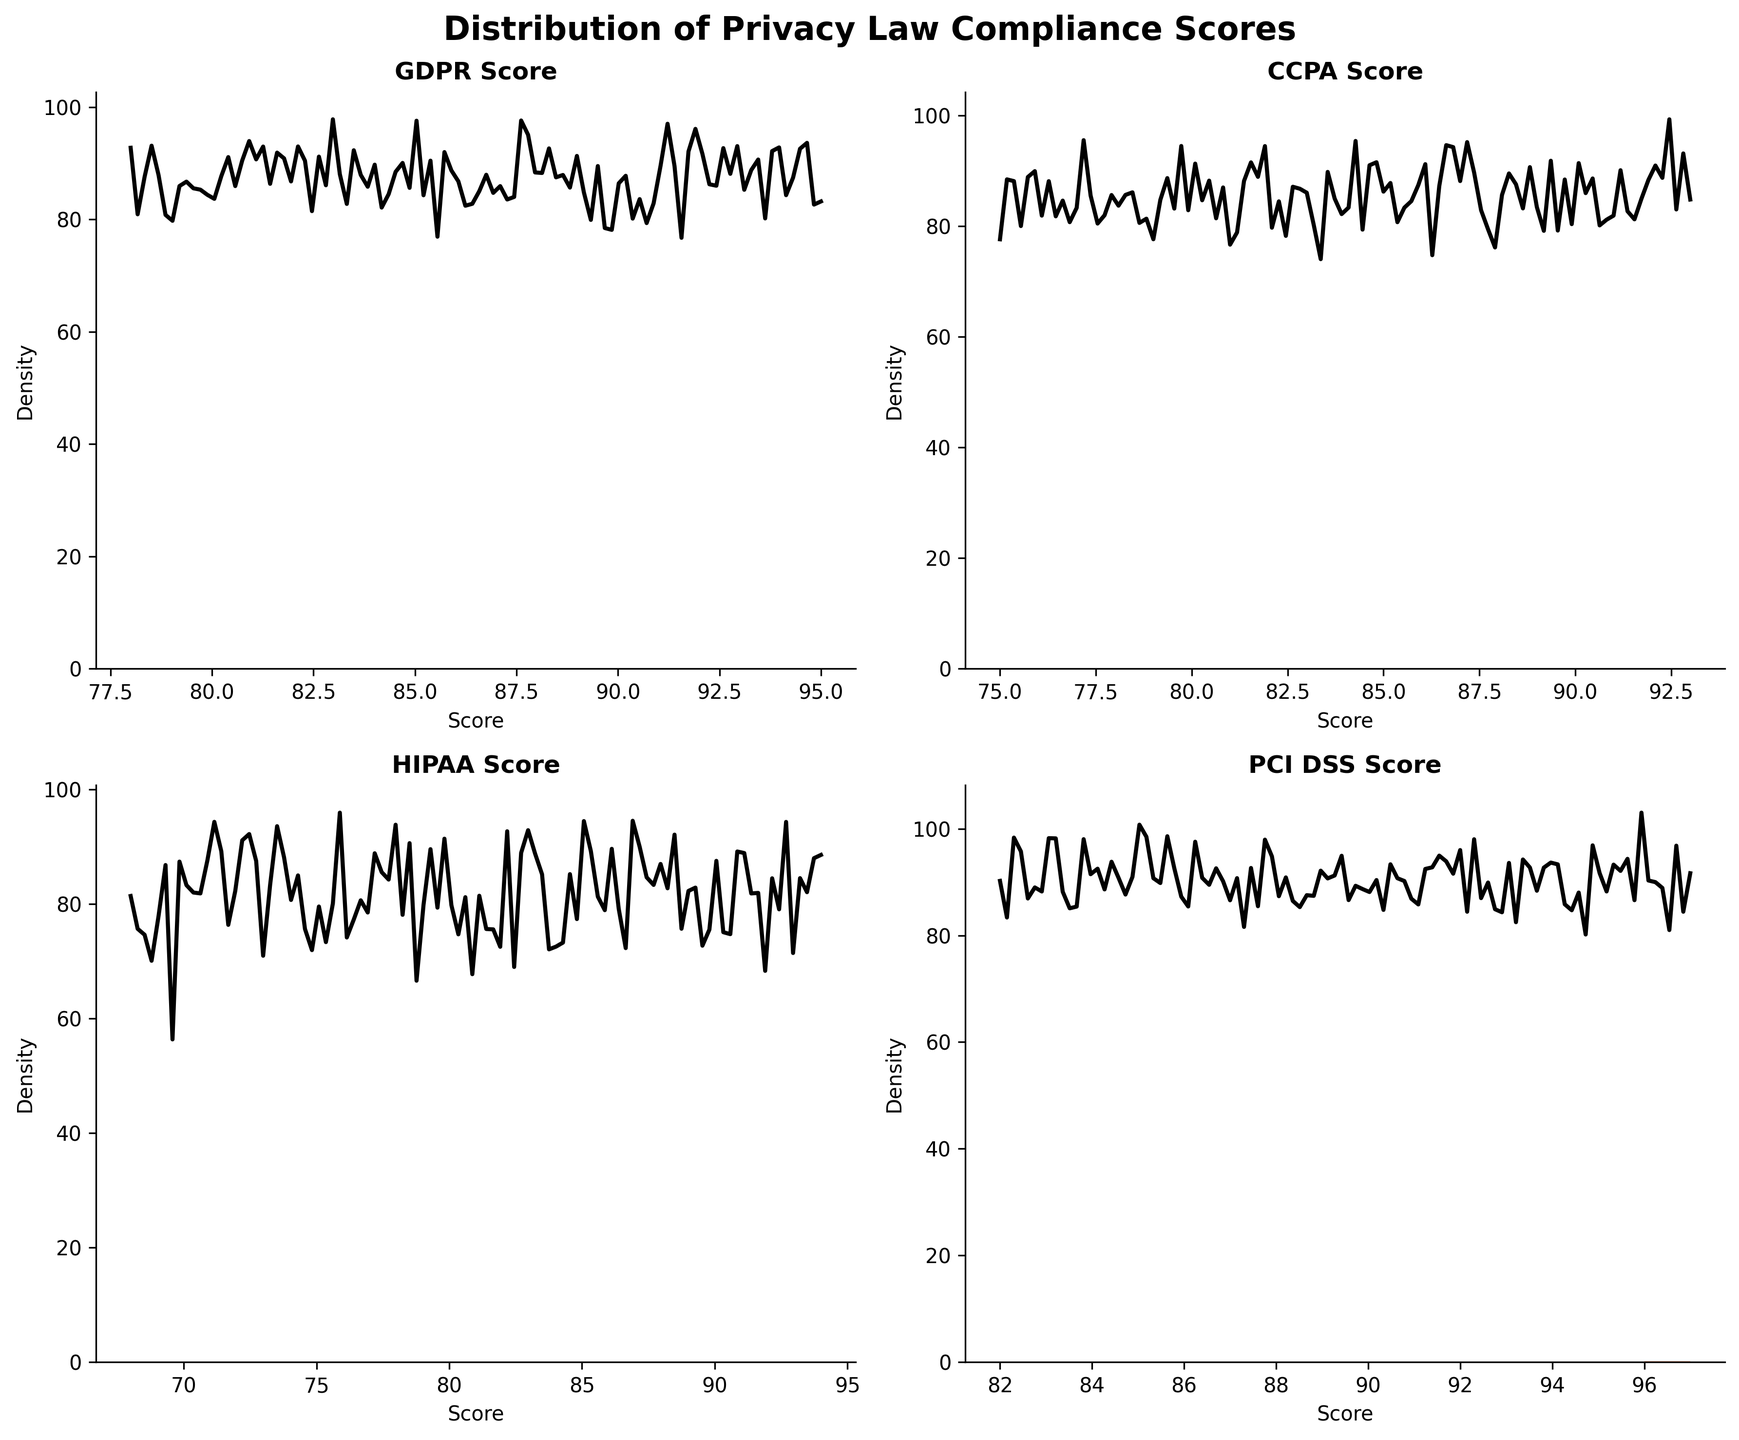Which compliance score has the highest density peak according to the plots? To find the highest density peak, examine the peak heights of the plots for GDPR, CCPA, HIPAA, and PCI DSS. The GDRP plot shows the highest peak.
Answer: GDPR Which compliance score seems to have the lowest overall variability? To determine the lowest overall variability, look for the compliance score with the narrowest spread in its density plot. The PCI DSS plot has the narrowest spread, indicating the least variability.
Answer: PCI DSS Between GDPR and CCPA scores, which one has a higher concentration of scores above 90? Compare the portion of the density plots above the 90 mark. The peak in the GDPR scores above 90 is more pronounced than the peak in the CCPA scores above 90.
Answer: GDPR Are the HIPAA scores more dispersed than the GDPR scores? Compare the spreads of the density plots for HIPAA and GDPR. The HIPAA scores show a wider spread compared to the GDPR scores, indicating higher dispersion.
Answer: Yes What is the most common range for PCI DSS scores? Identify the range where the PCI DSS density plot has its highest peak, which is the most common score range. The highest peaks in the PCI DSS plot are from 90 to 97.
Answer: 90-97 Which industry is most likely to have higher GDPR scores, based on the density peaks? Identify industries (Technology, Finance, etc.) with higher density peaks in GDPR scores. Finance and Technology industries' GDPR scores have high density peaks.
Answer: Finance and Technology Between the Telecom and Retail industries, which one has higher HIPAA scores on average? Compare the density plots of HIPAA scores for companies in the Telecommunications and Retail industries. The HIPAA scores distribution for the Telecom industry is centered at a higher score than for the Retail industry.
Answer: Telecom How does the density of CCPA scores compare to HIPAA scores at around 85? Compare the density peaks of the CCPA and HIPAA scores around the score of 85. The density of CCPA scores around 85 is slightly higher than that of HIPAA scores around 85.
Answer: CCPA Which score shows the broadest distribution across all companies? To find the broadest distribution, look for the density plot with the widest spread of scores. The HIPAA density plot displays the broadest distribution compared to GDPR, CCPA, and PCI DSS.
Answer: HIPAA Is there a compliance score with multiple prominent peaks, indicating multimodal distribution? Examine each density plot for multiple prominent peaks. The GDPR score density plot shows a more pronounced multimodal distribution compared to the others.
Answer: GDPR 